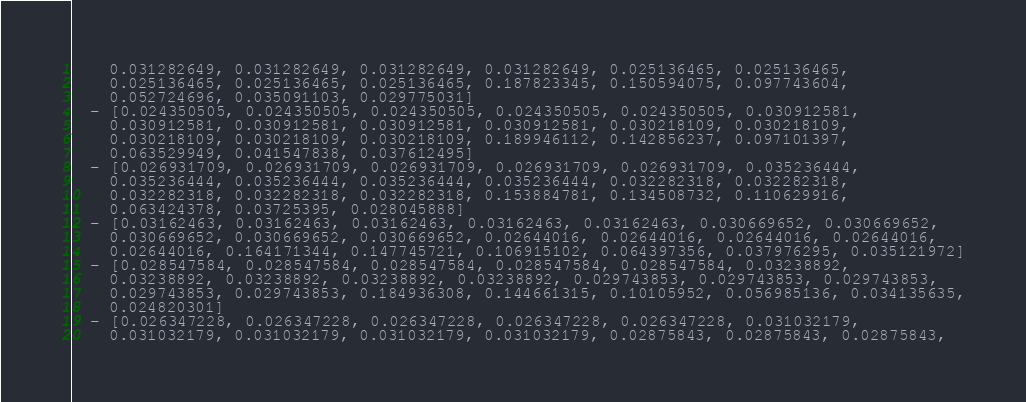<code> <loc_0><loc_0><loc_500><loc_500><_YAML_>    0.031282649, 0.031282649, 0.031282649, 0.031282649, 0.025136465, 0.025136465,
    0.025136465, 0.025136465, 0.025136465, 0.187823345, 0.150594075, 0.097743604,
    0.052724696, 0.035091103, 0.029775031]
  - [0.024350505, 0.024350505, 0.024350505, 0.024350505, 0.024350505, 0.030912581,
    0.030912581, 0.030912581, 0.030912581, 0.030912581, 0.030218109, 0.030218109,
    0.030218109, 0.030218109, 0.030218109, 0.189946112, 0.142856237, 0.097101397,
    0.063529949, 0.041547838, 0.037612495]
  - [0.026931709, 0.026931709, 0.026931709, 0.026931709, 0.026931709, 0.035236444,
    0.035236444, 0.035236444, 0.035236444, 0.035236444, 0.032282318, 0.032282318,
    0.032282318, 0.032282318, 0.032282318, 0.153884781, 0.134508732, 0.110629916,
    0.063424378, 0.03725395, 0.028045888]
  - [0.03162463, 0.03162463, 0.03162463, 0.03162463, 0.03162463, 0.030669652, 0.030669652,
    0.030669652, 0.030669652, 0.030669652, 0.02644016, 0.02644016, 0.02644016, 0.02644016,
    0.02644016, 0.164171344, 0.147745721, 0.106915102, 0.064397356, 0.037976295, 0.035121972]
  - [0.028547584, 0.028547584, 0.028547584, 0.028547584, 0.028547584, 0.03238892,
    0.03238892, 0.03238892, 0.03238892, 0.03238892, 0.029743853, 0.029743853, 0.029743853,
    0.029743853, 0.029743853, 0.184936308, 0.144661315, 0.10105952, 0.056985136, 0.034135635,
    0.024820301]
  - [0.026347228, 0.026347228, 0.026347228, 0.026347228, 0.026347228, 0.031032179,
    0.031032179, 0.031032179, 0.031032179, 0.031032179, 0.02875843, 0.02875843, 0.02875843,</code> 